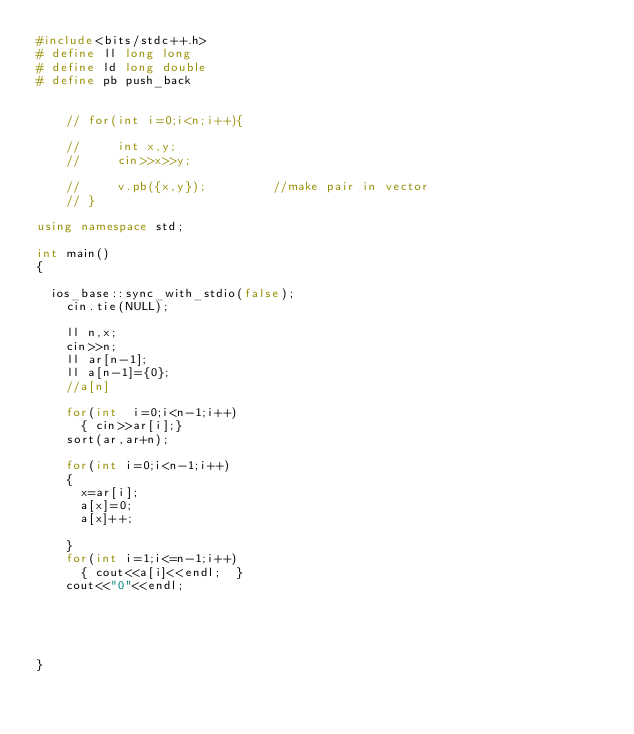<code> <loc_0><loc_0><loc_500><loc_500><_C++_>#include<bits/stdc++.h>
# define ll long long
# define ld long double
# define pb push_back
 
  
    // for(int i=0;i<n;i++){  
        
    //     int x,y;
    //     cin>>x>>y;
        
    //     v.pb({x,y});         //make pair in vector
    // }
 
using namespace std;
 
int main()
{
 
	ios_base::sync_with_stdio(false);
    cin.tie(NULL);
    
    ll n,x;
    cin>>n;
    ll ar[n-1];
    ll a[n-1]={0};
    //a[n]

    for(int  i=0;i<n-1;i++)
    	{ cin>>ar[i];}
    sort(ar,ar+n);
    
    for(int i=0;i<n-1;i++)
    {  
    	x=ar[i];
    	a[x]=0;
    	a[x]++;
    	
    }
    for(int i=1;i<=n-1;i++)
    	{ cout<<a[i]<<endl;  }
    cout<<"0"<<endl;





}</code> 